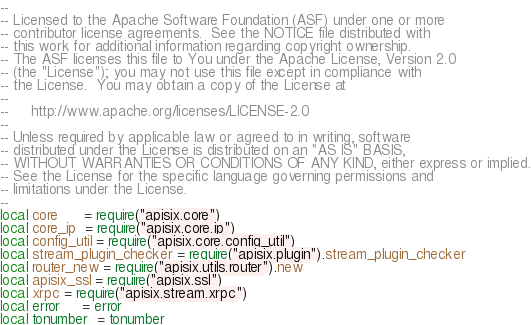Convert code to text. <code><loc_0><loc_0><loc_500><loc_500><_Lua_>--
-- Licensed to the Apache Software Foundation (ASF) under one or more
-- contributor license agreements.  See the NOTICE file distributed with
-- this work for additional information regarding copyright ownership.
-- The ASF licenses this file to You under the Apache License, Version 2.0
-- (the "License"); you may not use this file except in compliance with
-- the License.  You may obtain a copy of the License at
--
--     http://www.apache.org/licenses/LICENSE-2.0
--
-- Unless required by applicable law or agreed to in writing, software
-- distributed under the License is distributed on an "AS IS" BASIS,
-- WITHOUT WARRANTIES OR CONDITIONS OF ANY KIND, either express or implied.
-- See the License for the specific language governing permissions and
-- limitations under the License.
--
local core      = require("apisix.core")
local core_ip  = require("apisix.core.ip")
local config_util = require("apisix.core.config_util")
local stream_plugin_checker = require("apisix.plugin").stream_plugin_checker
local router_new = require("apisix.utils.router").new
local apisix_ssl = require("apisix.ssl")
local xrpc = require("apisix.stream.xrpc")
local error     = error
local tonumber  = tonumber</code> 